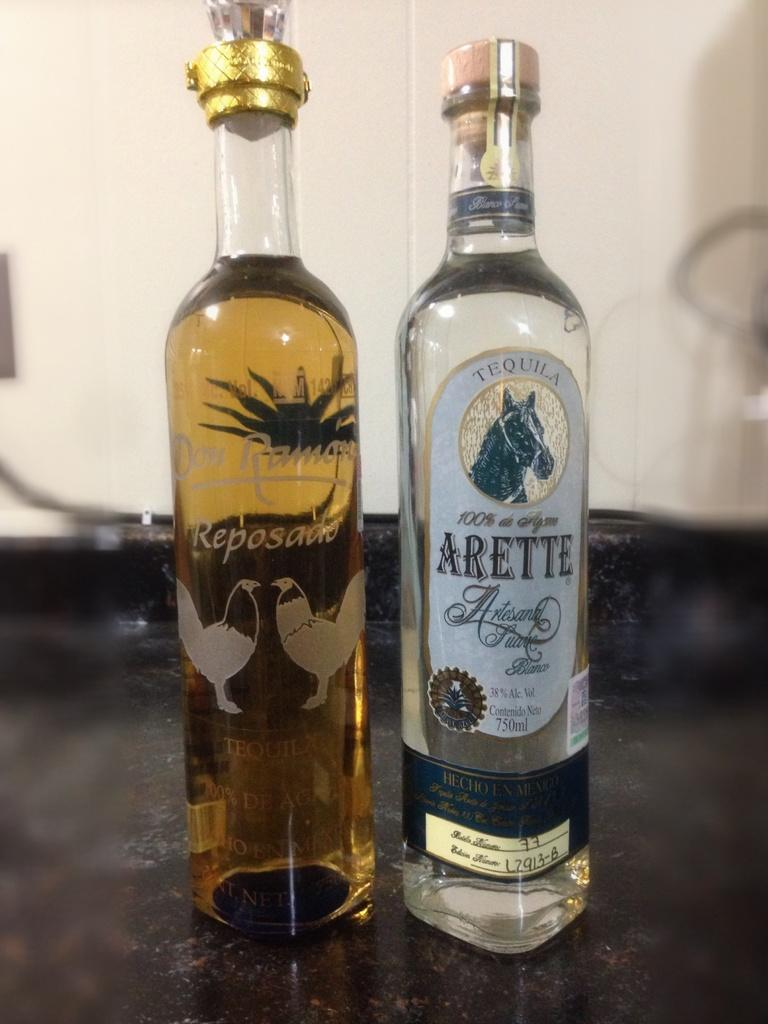<image>
Describe the image concisely. Bottle of Arette alcohol next to a bottle of Reposado. 